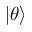Convert formula to latex. <formula><loc_0><loc_0><loc_500><loc_500>| \theta \rangle</formula> 